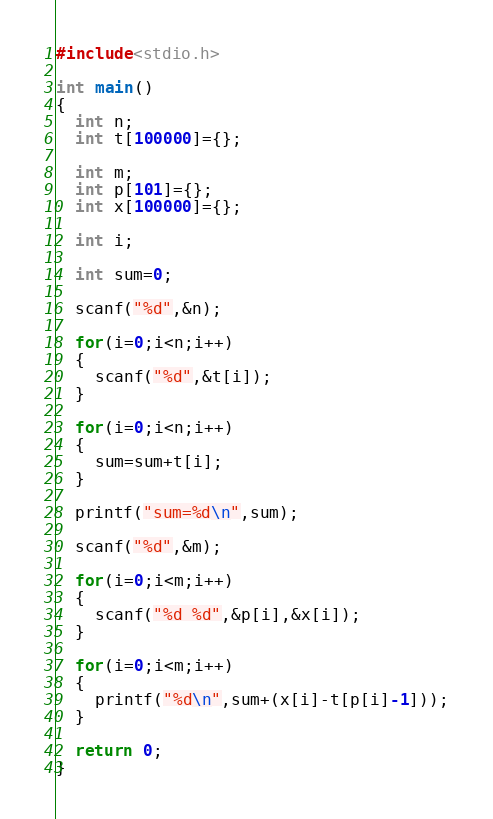Convert code to text. <code><loc_0><loc_0><loc_500><loc_500><_C_>#include<stdio.h>

int main()
{
  int n;
  int t[100000]={};
  
  int m;
  int p[101]={};
  int x[100000]={};
  
  int i;
  
  int sum=0;
  
  scanf("%d",&n);
  
  for(i=0;i<n;i++)
  {
    scanf("%d",&t[i]);
  }
  
  for(i=0;i<n;i++)
  {
    sum=sum+t[i];
  }
  
  printf("sum=%d\n",sum);
  
  scanf("%d",&m);
  
  for(i=0;i<m;i++)
  {
    scanf("%d %d",&p[i],&x[i]);
  }
   
  for(i=0;i<m;i++)
  {
    printf("%d\n",sum+(x[i]-t[p[i]-1]));
  }
  
  return 0;
}</code> 